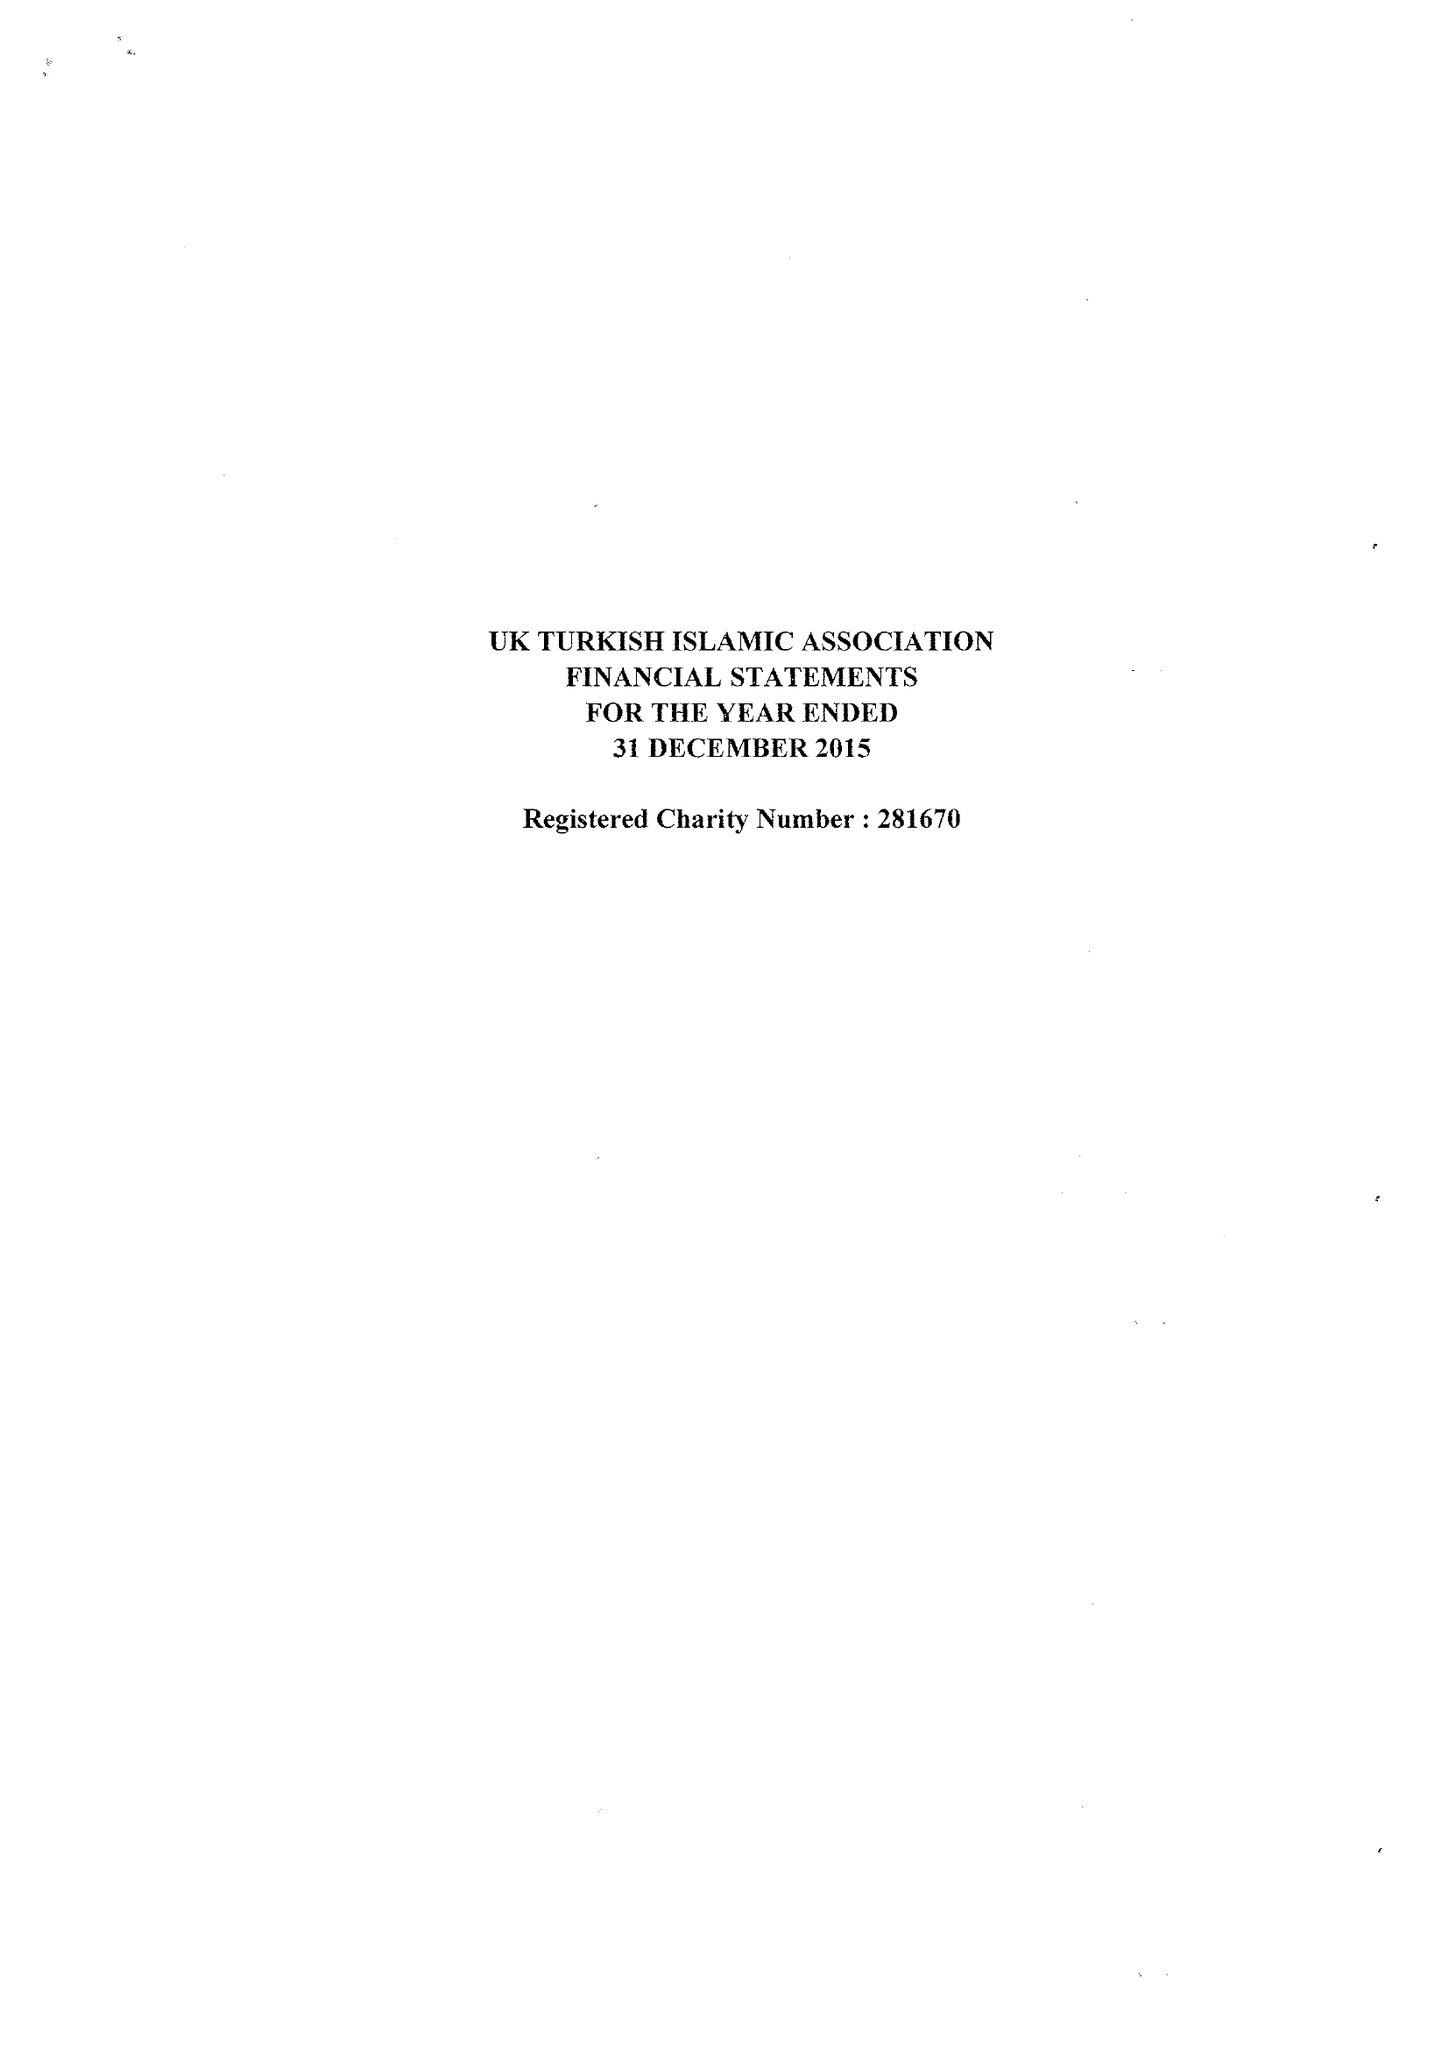What is the value for the report_date?
Answer the question using a single word or phrase. 2015-12-31 